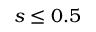Convert formula to latex. <formula><loc_0><loc_0><loc_500><loc_500>s \leq 0 . 5</formula> 